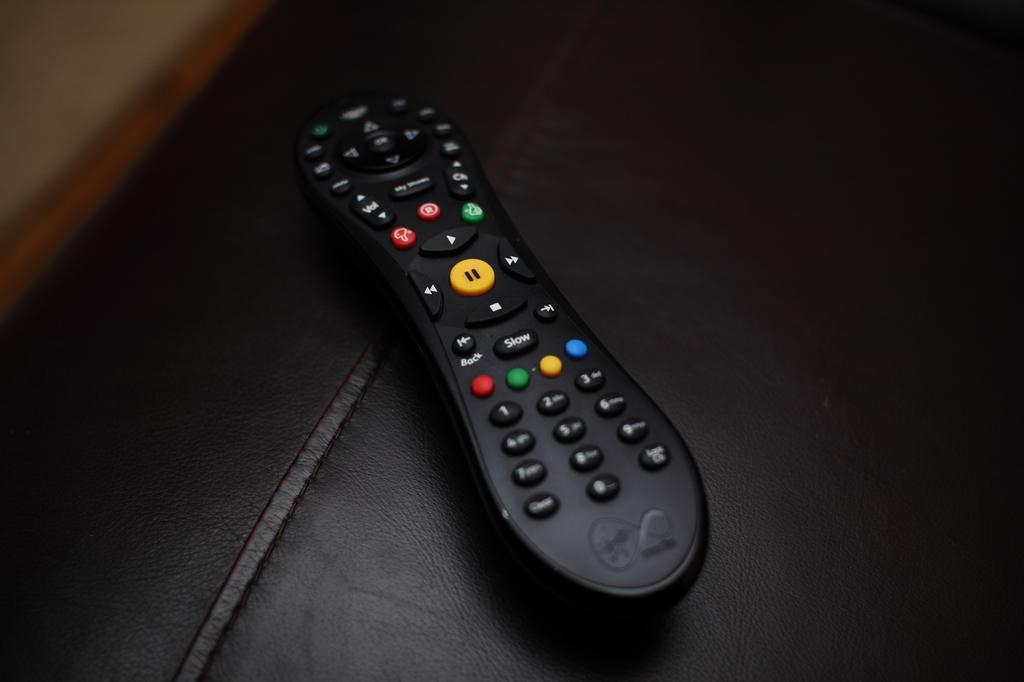What device is on the surface in the image? There is a remote on the surface. What else can be seen on the surface besides the remote? There is an object on the surface. How many steps are visible in the image? There are no steps visible in the image. What type of cracker is being eaten by the person in the image? There is no person or cracker present in the image. 